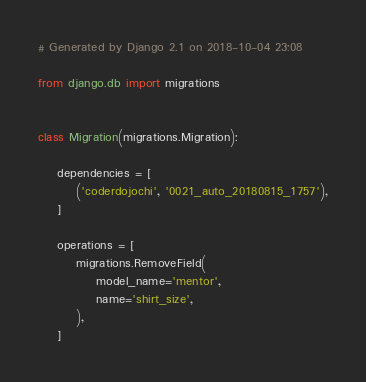<code> <loc_0><loc_0><loc_500><loc_500><_Python_># Generated by Django 2.1 on 2018-10-04 23:08

from django.db import migrations


class Migration(migrations.Migration):

    dependencies = [
        ('coderdojochi', '0021_auto_20180815_1757'),
    ]

    operations = [
        migrations.RemoveField(
            model_name='mentor',
            name='shirt_size',
        ),
    ]
</code> 